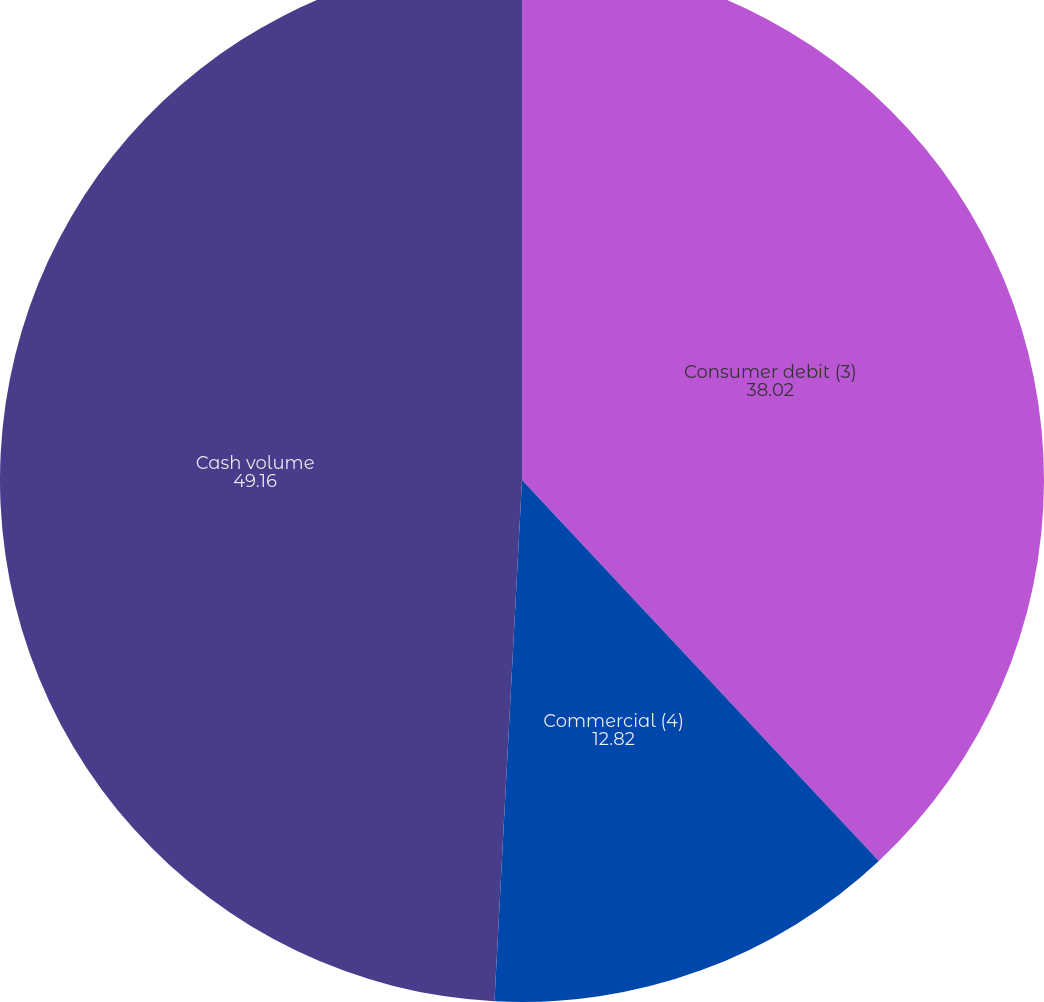Convert chart to OTSL. <chart><loc_0><loc_0><loc_500><loc_500><pie_chart><fcel>Consumer debit (3)<fcel>Commercial (4)<fcel>Cash volume<nl><fcel>38.02%<fcel>12.82%<fcel>49.16%<nl></chart> 